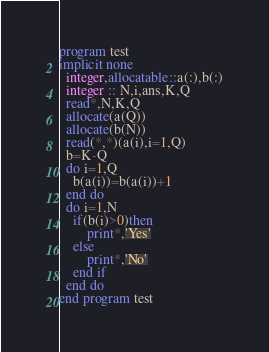<code> <loc_0><loc_0><loc_500><loc_500><_FORTRAN_>program test
implicit none
  integer,allocatable::a(:),b(:)
  integer :: N,i,ans,K,Q
  read*,N,K,Q
  allocate(a(Q))
  allocate(b(N))
  read(*,*)(a(i),i=1,Q)
  b=K-Q
  do i=1,Q
  	b(a(i))=b(a(i))+1
  end do
  do i=1,N
  	if(b(i)>0)then
    	print*,'Yes'
    else 
    	print*,'No'
    end if
  end do
end program test</code> 